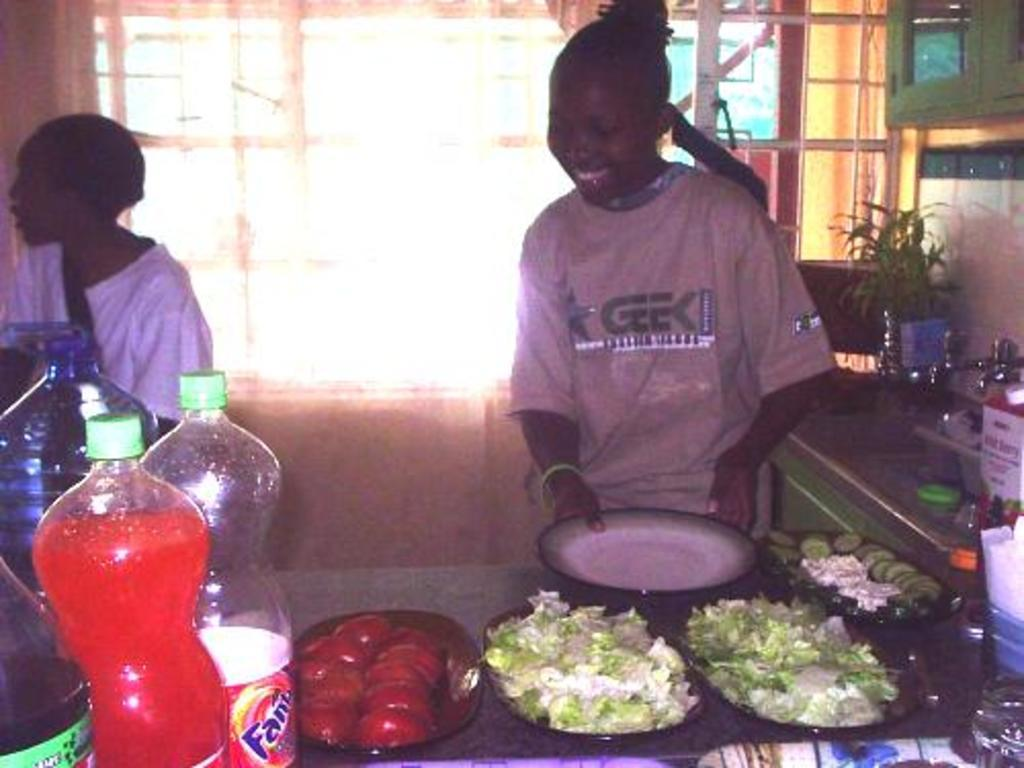How many people are present in the image? There are two persons standing in the image. What is one person holding in the image? One person is holding a plate. How many plates are on the table in the image? There are four plates on the table. What can be found on the table in the image? There is food and bottles on the table. What is the size of the paper on the table in the image? There is no paper present on the table in the image. 